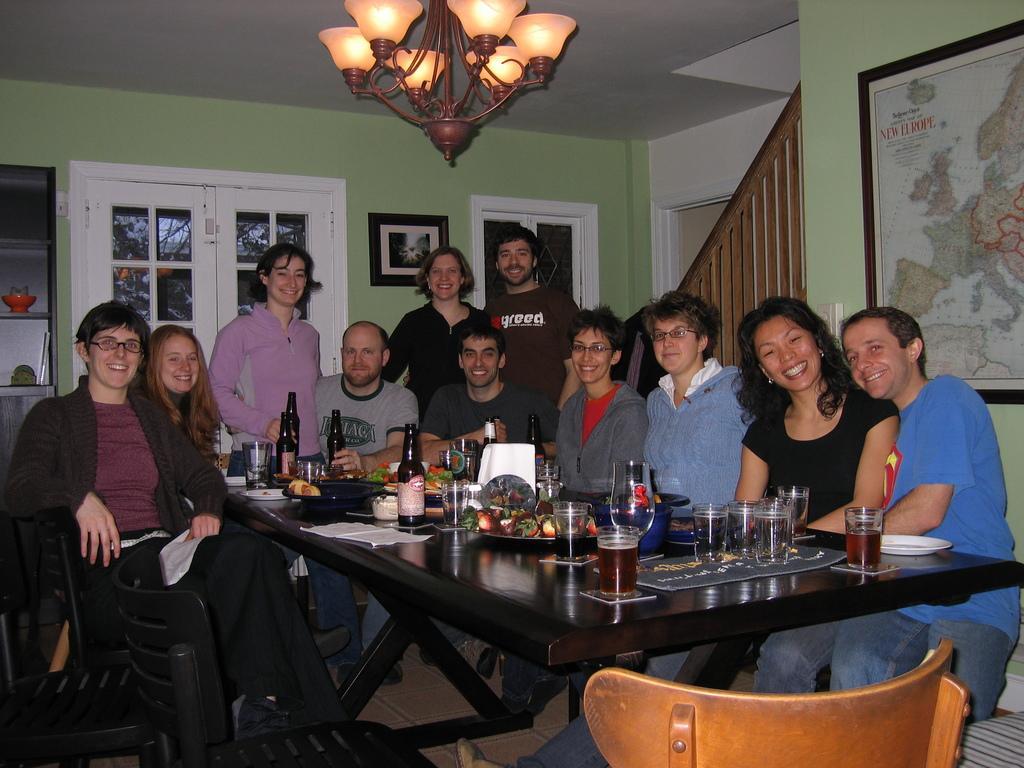Describe this image in one or two sentences. There are many people sitting around the table and smiling. Some are standing. On the table there are bottles , glasses, plates, food items. And there are chairs. In the background there is a wall. And there is a photo frame on the wall. There is a window on the wall. There is a staircase. There is a chandelier on the ceiling. 